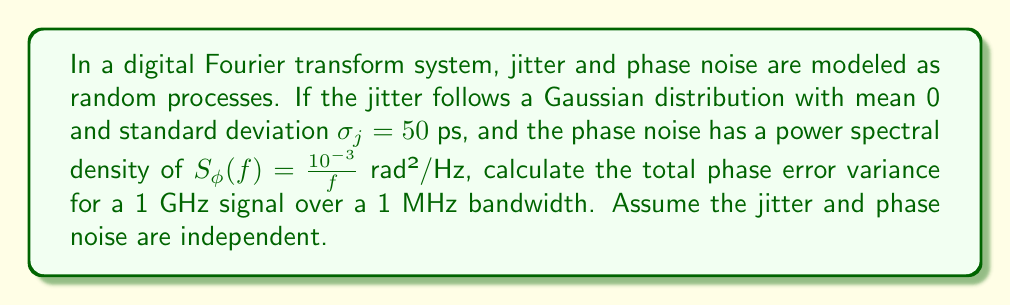Solve this math problem. To solve this problem, we need to consider both jitter and phase noise contributions:

1. Jitter contribution:
   The jitter follows a Gaussian distribution with $\sigma_j = 50$ ps.
   For a 1 GHz signal, the phase error due to jitter is:
   $$\sigma_{\phi_j}^2 = (2\pi f \sigma_j)^2 = (2\pi \cdot 10^9 \cdot 50 \cdot 10^{-12})^2 = 0.0986 \text{ rad}^2$$

2. Phase noise contribution:
   The phase noise has a power spectral density of $S_\phi(f) = \frac{10^{-3}}{f}$ rad²/Hz.
   To find the phase error variance due to phase noise, we integrate over the bandwidth:
   $$\sigma_{\phi_n}^2 = \int_{f_L}^{f_H} S_\phi(f) df = \int_{1}^{10^6} \frac{10^{-3}}{f} df = 10^{-3} \ln(10^6) = 13.82 \cdot 10^{-3} \text{ rad}^2$$
   Where $f_L = 1$ Hz and $f_H = 1$ MHz.

3. Total phase error variance:
   Since jitter and phase noise are assumed independent, we can add their variances:
   $$\sigma_{\phi_{total}}^2 = \sigma_{\phi_j}^2 + \sigma_{\phi_n}^2 = 0.0986 + 0.01382 = 0.1124 \text{ rad}^2$$
Answer: 0.1124 rad² 